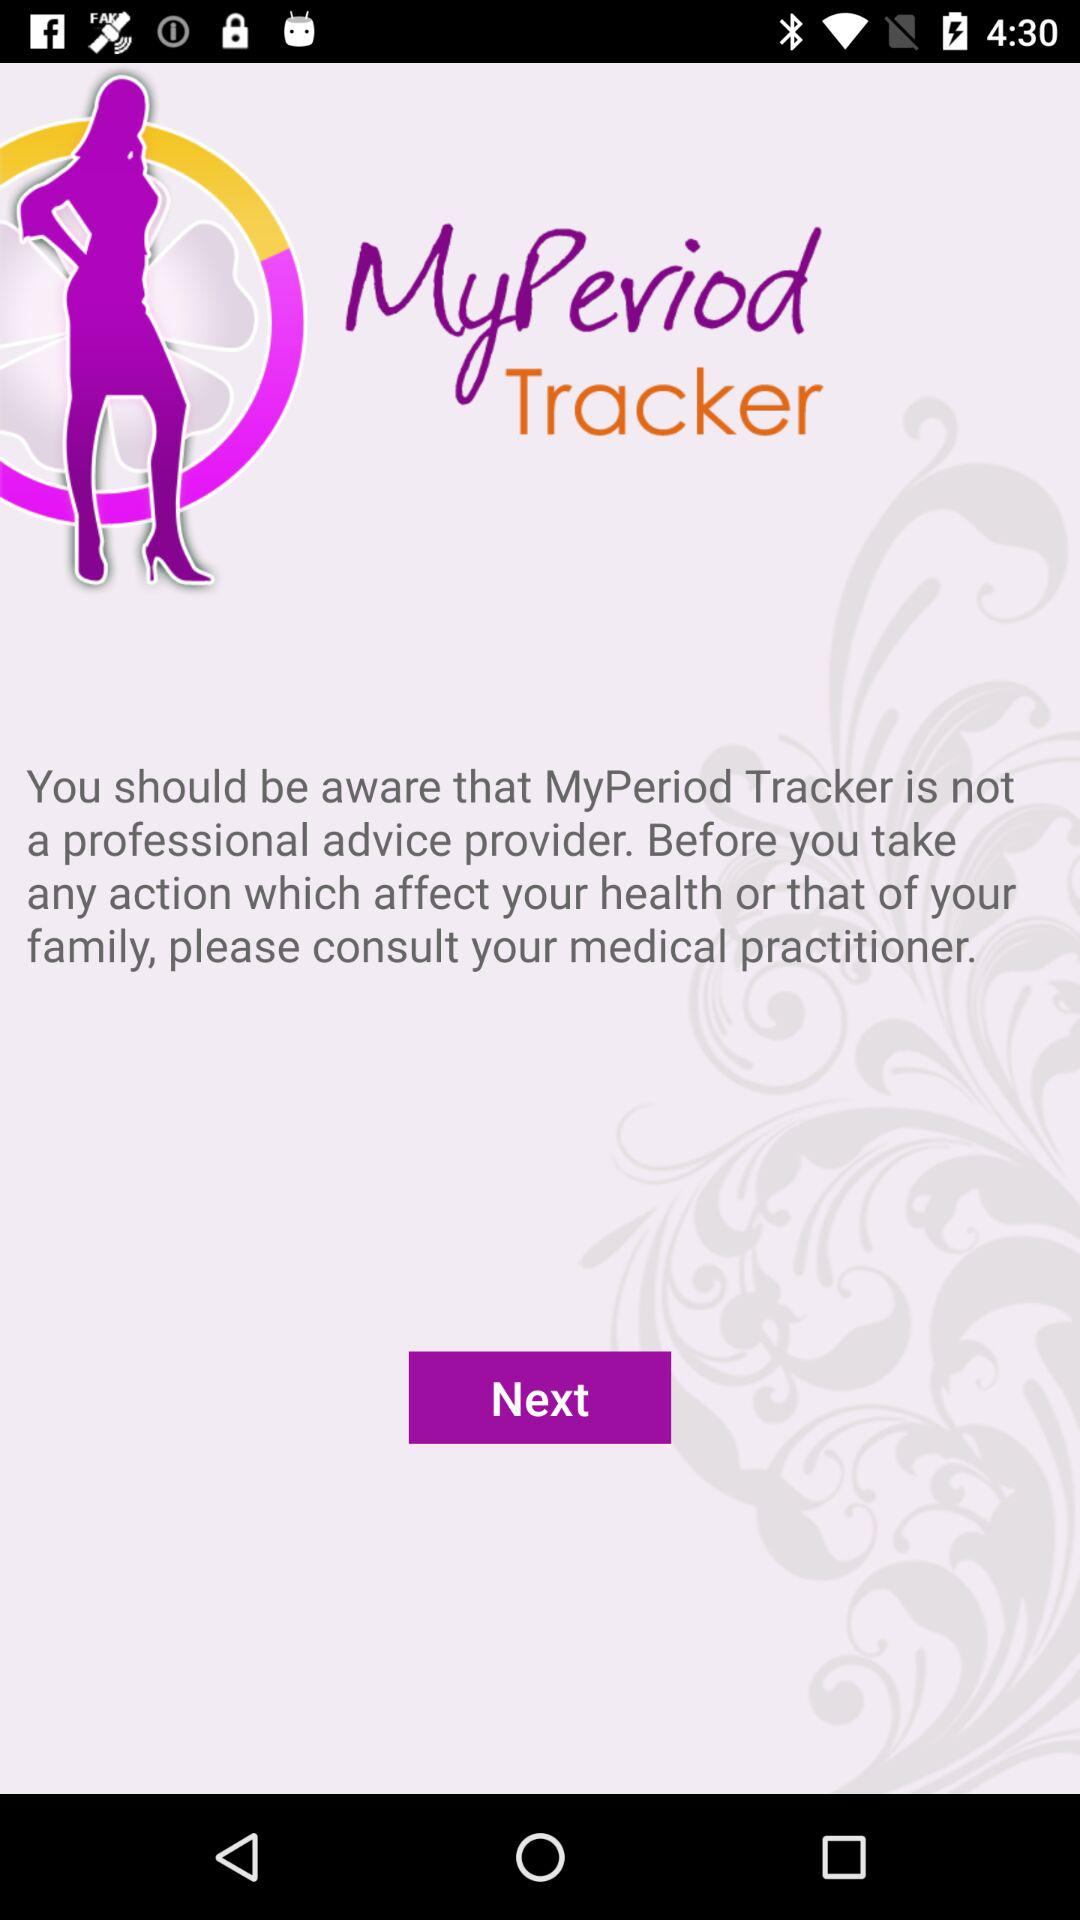What is the application name? The application name is "MyPeriod Tracker". 